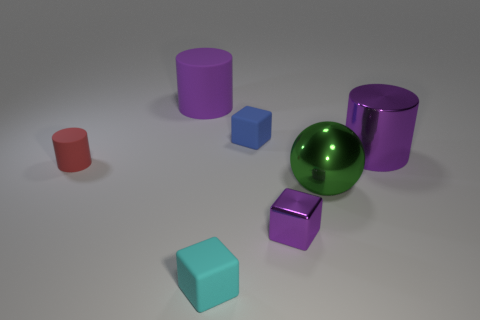Subtract all tiny blue blocks. How many blocks are left? 2 Add 3 green balls. How many objects exist? 10 Subtract 3 blocks. How many blocks are left? 0 Subtract all blocks. How many objects are left? 4 Subtract all purple blocks. How many blocks are left? 2 Subtract all gray cubes. How many purple cylinders are left? 2 Subtract all red balls. Subtract all blue cylinders. How many balls are left? 1 Subtract all small green objects. Subtract all large green things. How many objects are left? 6 Add 5 big rubber cylinders. How many big rubber cylinders are left? 6 Add 1 tiny metallic things. How many tiny metallic things exist? 2 